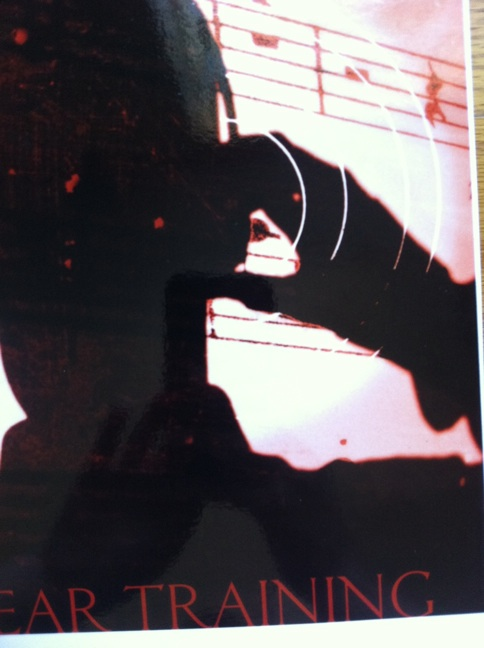What can be inferred about the subject of this image? The subject seems to be related to music, specifically ear training. The silhouette of a person and the musical staff in the background suggest this image pertains to the process of honing one's ability to recognize and understand musical elements. Can you elaborate on how ear training is beneficial for musicians? Ear training is essential for musicians as it enhances their ability to identify pitches, intervals, melody, chords, and rhythms purely by hearing. This skill allows musicians to transcribe music accurately, improve their improvisation, and collaborate more effectively in ensemble settings. It also sharpens their musical intuition, making it easier to internalize and reproduce complex musical pieces. 